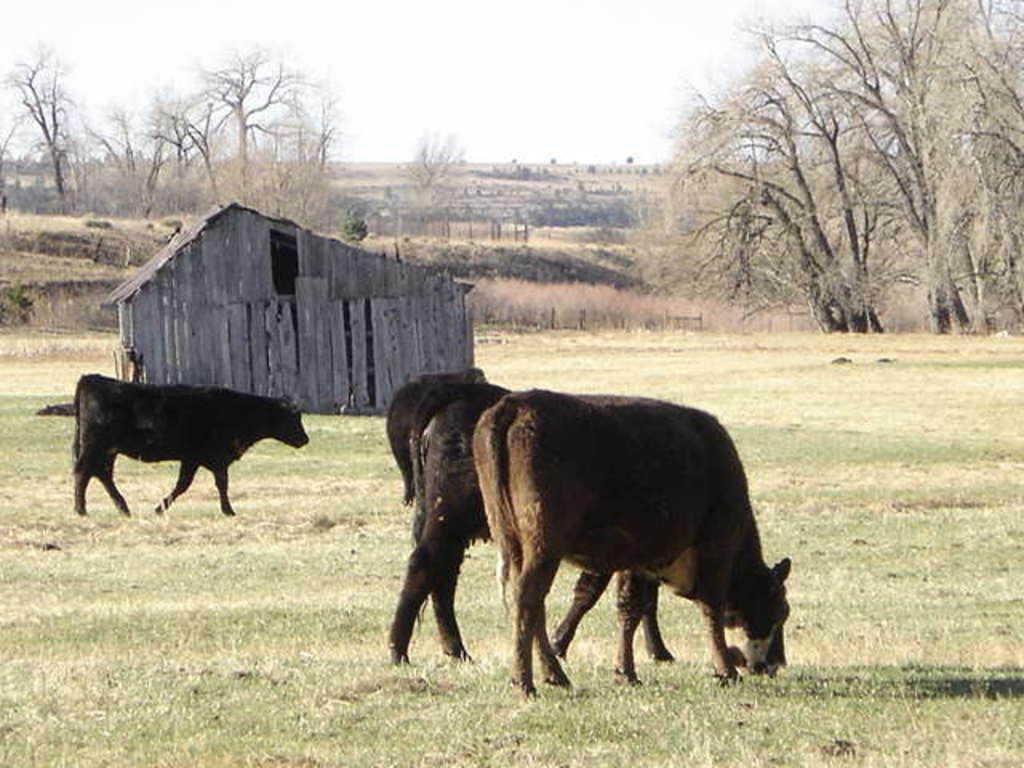In one or two sentences, can you explain what this image depicts? In this image there is cattle. At the bottom of the image there is grass on the surface. Behind the cattle there is a wooden hut. In the background of the image there are trees and sky. 